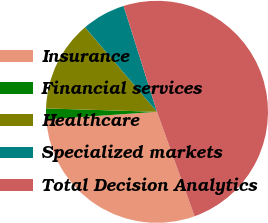<chart> <loc_0><loc_0><loc_500><loc_500><pie_chart><fcel>Insurance<fcel>Financial services<fcel>Healthcare<fcel>Specialized markets<fcel>Total Decision Analytics<nl><fcel>29.41%<fcel>1.58%<fcel>13.29%<fcel>6.36%<fcel>49.36%<nl></chart> 